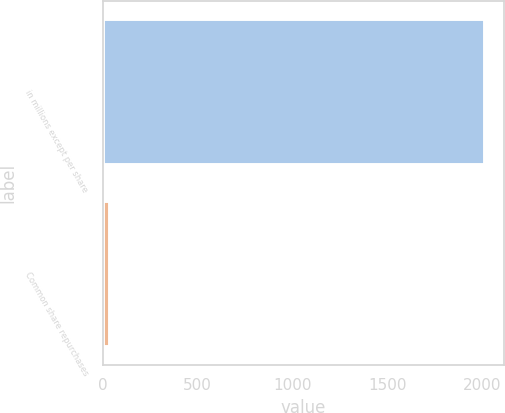Convert chart to OTSL. <chart><loc_0><loc_0><loc_500><loc_500><bar_chart><fcel>in millions except per share<fcel>Common share repurchases<nl><fcel>2016<fcel>36.6<nl></chart> 